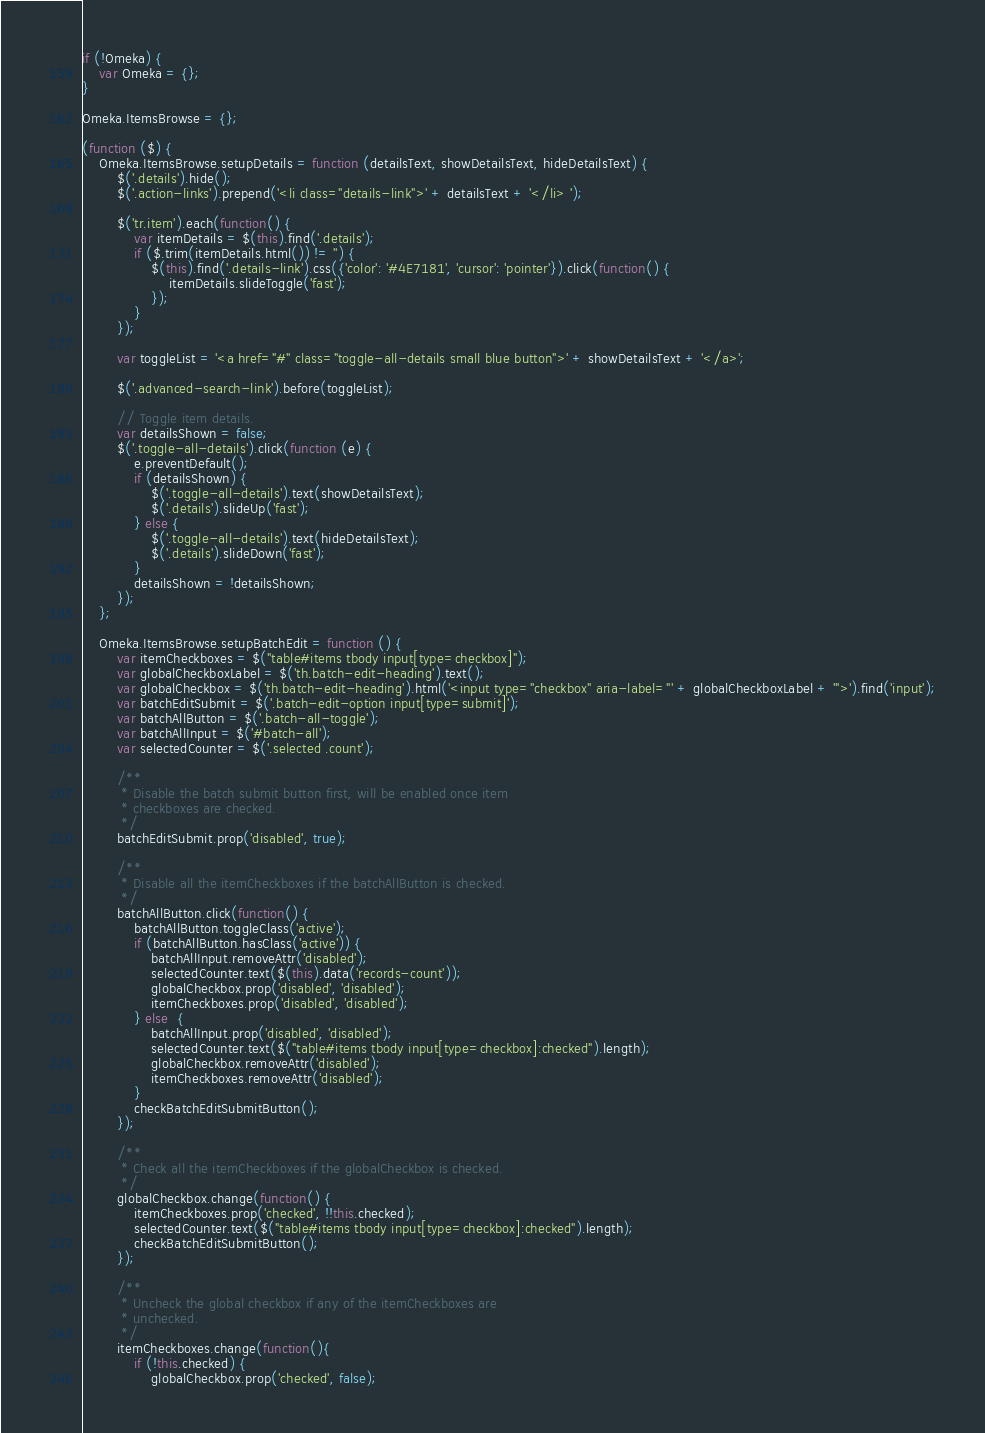<code> <loc_0><loc_0><loc_500><loc_500><_JavaScript_>if (!Omeka) {
    var Omeka = {};
}

Omeka.ItemsBrowse = {};

(function ($) {
    Omeka.ItemsBrowse.setupDetails = function (detailsText, showDetailsText, hideDetailsText) {
        $('.details').hide();
        $('.action-links').prepend('<li class="details-link">' + detailsText + '</li> ');

        $('tr.item').each(function() {
            var itemDetails = $(this).find('.details');
            if ($.trim(itemDetails.html()) != '') {
                $(this).find('.details-link').css({'color': '#4E7181', 'cursor': 'pointer'}).click(function() {
                    itemDetails.slideToggle('fast');
                });
            }
        });

        var toggleList = '<a href="#" class="toggle-all-details small blue button">' + showDetailsText + '</a>';

        $('.advanced-search-link').before(toggleList);

        // Toggle item details.
        var detailsShown = false;
        $('.toggle-all-details').click(function (e) {
            e.preventDefault();
            if (detailsShown) {
            	$('.toggle-all-details').text(showDetailsText);
            	$('.details').slideUp('fast');
            } else {
            	$('.toggle-all-details').text(hideDetailsText);
            	$('.details').slideDown('fast');
            }
            detailsShown = !detailsShown;
        });
    };

    Omeka.ItemsBrowse.setupBatchEdit = function () {
        var itemCheckboxes = $("table#items tbody input[type=checkbox]");
        var globalCheckboxLabel = $('th.batch-edit-heading').text();
        var globalCheckbox = $('th.batch-edit-heading').html('<input type="checkbox" aria-label="' + globalCheckboxLabel + '">').find('input');
        var batchEditSubmit = $('.batch-edit-option input[type=submit]');
        var batchAllButton = $('.batch-all-toggle');
        var batchAllInput = $('#batch-all');
        var selectedCounter = $('.selected .count');

        /**
         * Disable the batch submit button first, will be enabled once item
         * checkboxes are checked.
         */
        batchEditSubmit.prop('disabled', true);

        /**
         * Disable all the itemCheckboxes if the batchAllButton is checked.
         */
        batchAllButton.click(function() {
            batchAllButton.toggleClass('active');
            if (batchAllButton.hasClass('active')) {
                batchAllInput.removeAttr('disabled');
                selectedCounter.text($(this).data('records-count'));
                globalCheckbox.prop('disabled', 'disabled');
                itemCheckboxes.prop('disabled', 'disabled');
            } else  {
                batchAllInput.prop('disabled', 'disabled');
                selectedCounter.text($("table#items tbody input[type=checkbox]:checked").length);
                globalCheckbox.removeAttr('disabled');
                itemCheckboxes.removeAttr('disabled');
            }
            checkBatchEditSubmitButton();
        });

        /**
         * Check all the itemCheckboxes if the globalCheckbox is checked.
         */
        globalCheckbox.change(function() {
            itemCheckboxes.prop('checked', !!this.checked);
            selectedCounter.text($("table#items tbody input[type=checkbox]:checked").length);
            checkBatchEditSubmitButton();
        });

        /**
         * Uncheck the global checkbox if any of the itemCheckboxes are
         * unchecked.
         */
        itemCheckboxes.change(function(){
            if (!this.checked) {
                globalCheckbox.prop('checked', false);</code> 